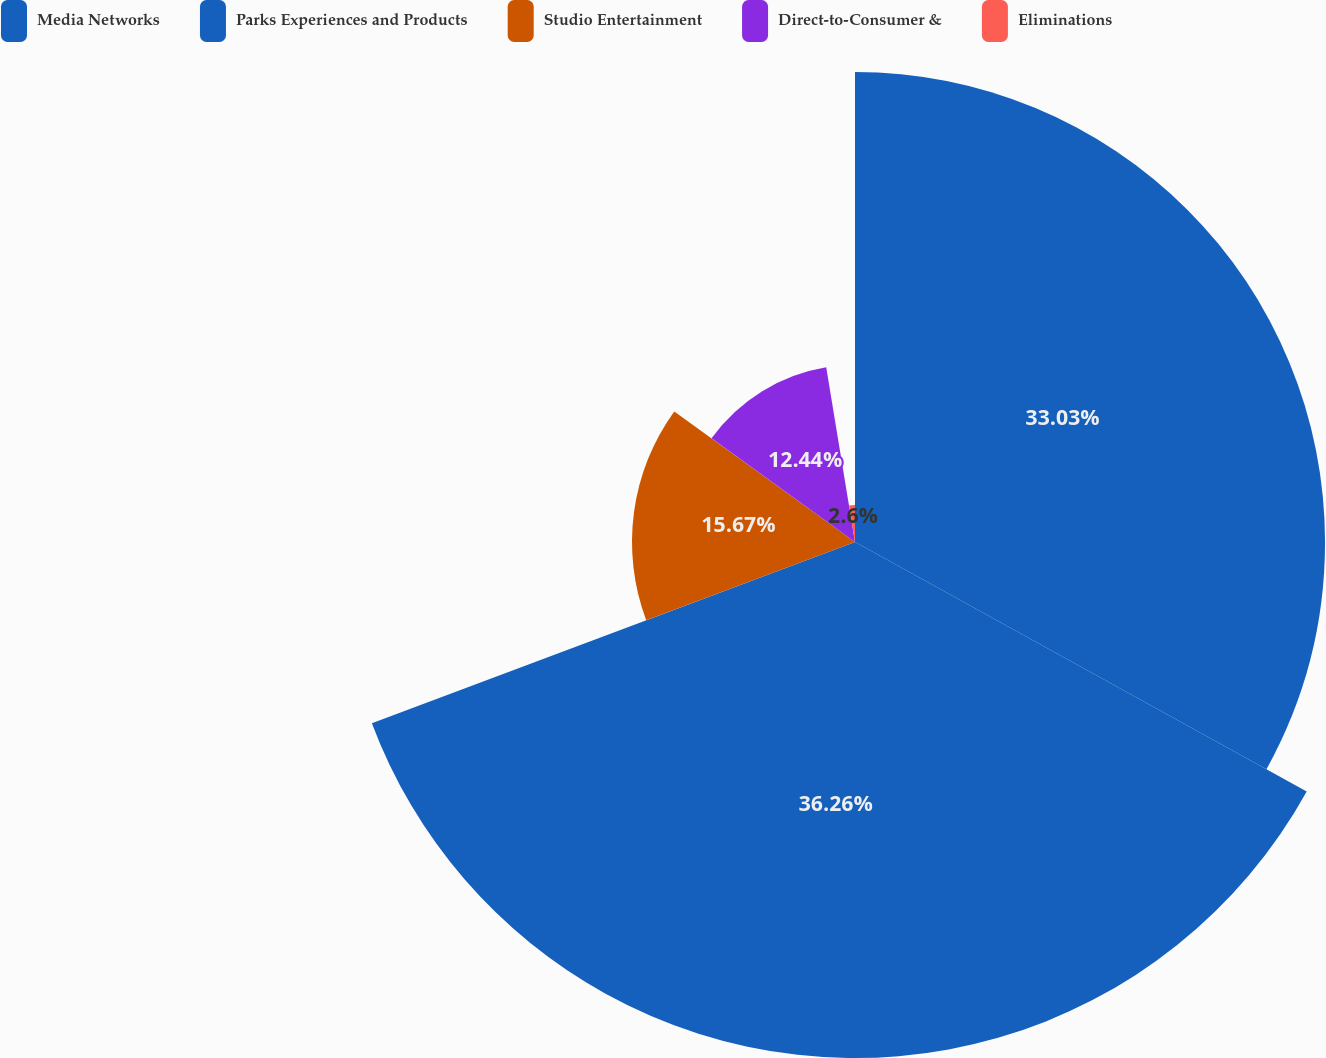Convert chart to OTSL. <chart><loc_0><loc_0><loc_500><loc_500><pie_chart><fcel>Media Networks<fcel>Parks Experiences and Products<fcel>Studio Entertainment<fcel>Direct-to-Consumer &<fcel>Eliminations<nl><fcel>33.03%<fcel>36.26%<fcel>15.67%<fcel>12.44%<fcel>2.6%<nl></chart> 